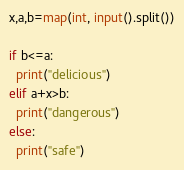Convert code to text. <code><loc_0><loc_0><loc_500><loc_500><_Python_>x,a,b=map(int, input().split())

if b<=a:
  print("delicious")
elif a+x>b:
  print("dangerous")
else:
  print("safe")</code> 